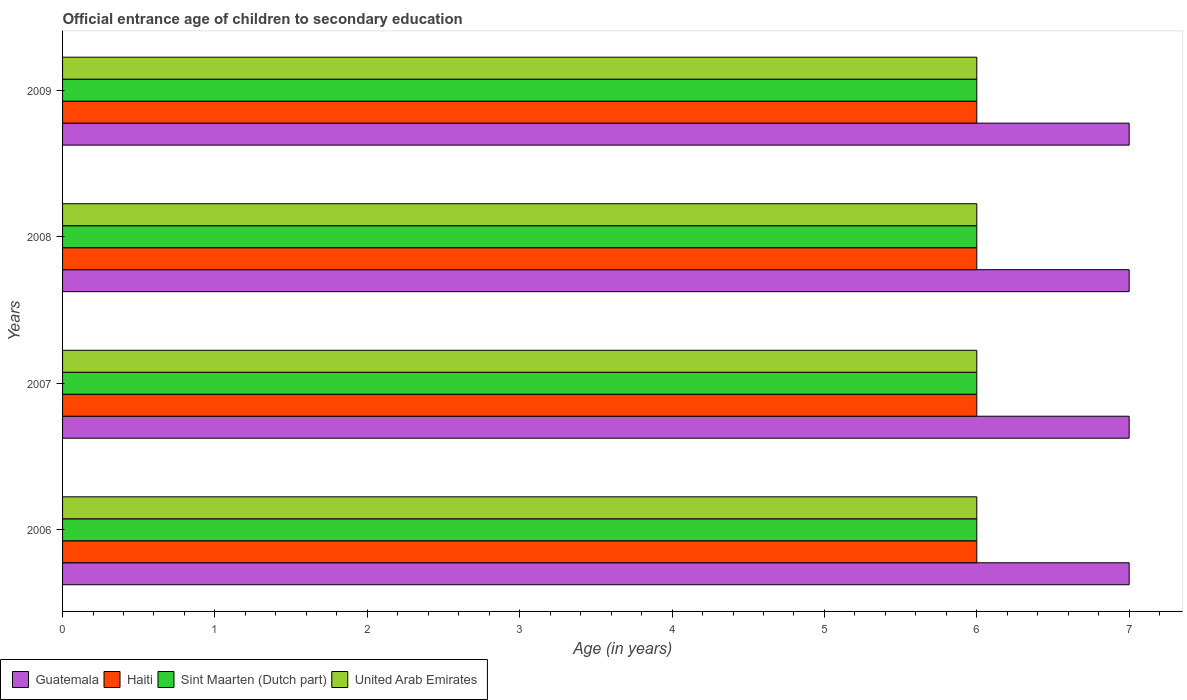How many different coloured bars are there?
Your answer should be compact. 4. How many groups of bars are there?
Give a very brief answer. 4. Are the number of bars per tick equal to the number of legend labels?
Your answer should be very brief. Yes. Are the number of bars on each tick of the Y-axis equal?
Your response must be concise. Yes. In how many cases, is the number of bars for a given year not equal to the number of legend labels?
Keep it short and to the point. 0. What is the secondary school starting age of children in Sint Maarten (Dutch part) in 2009?
Make the answer very short. 6. Across all years, what is the maximum secondary school starting age of children in Haiti?
Keep it short and to the point. 6. Across all years, what is the minimum secondary school starting age of children in Haiti?
Provide a succinct answer. 6. In which year was the secondary school starting age of children in United Arab Emirates maximum?
Offer a very short reply. 2006. What is the total secondary school starting age of children in Guatemala in the graph?
Your answer should be compact. 28. What is the difference between the secondary school starting age of children in Guatemala in 2009 and the secondary school starting age of children in Haiti in 2007?
Keep it short and to the point. 1. In the year 2007, what is the difference between the secondary school starting age of children in Guatemala and secondary school starting age of children in United Arab Emirates?
Provide a succinct answer. 1. Is the secondary school starting age of children in United Arab Emirates in 2008 less than that in 2009?
Your answer should be very brief. No. Is the difference between the secondary school starting age of children in Guatemala in 2008 and 2009 greater than the difference between the secondary school starting age of children in United Arab Emirates in 2008 and 2009?
Provide a succinct answer. No. Is the sum of the secondary school starting age of children in Sint Maarten (Dutch part) in 2006 and 2009 greater than the maximum secondary school starting age of children in United Arab Emirates across all years?
Provide a short and direct response. Yes. Is it the case that in every year, the sum of the secondary school starting age of children in United Arab Emirates and secondary school starting age of children in Haiti is greater than the sum of secondary school starting age of children in Sint Maarten (Dutch part) and secondary school starting age of children in Guatemala?
Offer a very short reply. No. What does the 1st bar from the top in 2007 represents?
Make the answer very short. United Arab Emirates. What does the 2nd bar from the bottom in 2008 represents?
Your answer should be very brief. Haiti. How many years are there in the graph?
Give a very brief answer. 4. How are the legend labels stacked?
Your answer should be very brief. Horizontal. What is the title of the graph?
Keep it short and to the point. Official entrance age of children to secondary education. Does "Liechtenstein" appear as one of the legend labels in the graph?
Make the answer very short. No. What is the label or title of the X-axis?
Offer a very short reply. Age (in years). What is the Age (in years) in Guatemala in 2006?
Keep it short and to the point. 7. What is the Age (in years) of Sint Maarten (Dutch part) in 2006?
Provide a short and direct response. 6. What is the Age (in years) of Guatemala in 2007?
Keep it short and to the point. 7. What is the Age (in years) of United Arab Emirates in 2007?
Provide a short and direct response. 6. What is the Age (in years) of Haiti in 2008?
Offer a very short reply. 6. What is the Age (in years) in Sint Maarten (Dutch part) in 2008?
Your answer should be compact. 6. What is the Age (in years) in Haiti in 2009?
Provide a short and direct response. 6. Across all years, what is the maximum Age (in years) in Guatemala?
Give a very brief answer. 7. Across all years, what is the maximum Age (in years) in Sint Maarten (Dutch part)?
Your answer should be very brief. 6. Across all years, what is the minimum Age (in years) in Haiti?
Give a very brief answer. 6. What is the total Age (in years) in Guatemala in the graph?
Provide a succinct answer. 28. What is the difference between the Age (in years) of Haiti in 2006 and that in 2007?
Make the answer very short. 0. What is the difference between the Age (in years) of United Arab Emirates in 2006 and that in 2007?
Your answer should be very brief. 0. What is the difference between the Age (in years) of Haiti in 2006 and that in 2008?
Offer a very short reply. 0. What is the difference between the Age (in years) in Sint Maarten (Dutch part) in 2006 and that in 2008?
Offer a terse response. 0. What is the difference between the Age (in years) in Haiti in 2006 and that in 2009?
Keep it short and to the point. 0. What is the difference between the Age (in years) in Sint Maarten (Dutch part) in 2006 and that in 2009?
Your response must be concise. 0. What is the difference between the Age (in years) in Guatemala in 2007 and that in 2008?
Give a very brief answer. 0. What is the difference between the Age (in years) of Sint Maarten (Dutch part) in 2007 and that in 2008?
Ensure brevity in your answer.  0. What is the difference between the Age (in years) of United Arab Emirates in 2007 and that in 2008?
Your answer should be very brief. 0. What is the difference between the Age (in years) in Guatemala in 2007 and that in 2009?
Your answer should be compact. 0. What is the difference between the Age (in years) of Haiti in 2007 and that in 2009?
Your response must be concise. 0. What is the difference between the Age (in years) in Sint Maarten (Dutch part) in 2007 and that in 2009?
Make the answer very short. 0. What is the difference between the Age (in years) of Guatemala in 2008 and that in 2009?
Offer a terse response. 0. What is the difference between the Age (in years) of Sint Maarten (Dutch part) in 2008 and that in 2009?
Give a very brief answer. 0. What is the difference between the Age (in years) in Guatemala in 2006 and the Age (in years) in Sint Maarten (Dutch part) in 2007?
Keep it short and to the point. 1. What is the difference between the Age (in years) in Haiti in 2006 and the Age (in years) in Sint Maarten (Dutch part) in 2007?
Ensure brevity in your answer.  0. What is the difference between the Age (in years) of Haiti in 2006 and the Age (in years) of United Arab Emirates in 2007?
Offer a very short reply. 0. What is the difference between the Age (in years) of Guatemala in 2006 and the Age (in years) of Haiti in 2008?
Make the answer very short. 1. What is the difference between the Age (in years) in Guatemala in 2006 and the Age (in years) in United Arab Emirates in 2008?
Your answer should be very brief. 1. What is the difference between the Age (in years) of Sint Maarten (Dutch part) in 2006 and the Age (in years) of United Arab Emirates in 2008?
Make the answer very short. 0. What is the difference between the Age (in years) of Guatemala in 2006 and the Age (in years) of Haiti in 2009?
Make the answer very short. 1. What is the difference between the Age (in years) of Guatemala in 2006 and the Age (in years) of Sint Maarten (Dutch part) in 2009?
Offer a very short reply. 1. What is the difference between the Age (in years) in Guatemala in 2006 and the Age (in years) in United Arab Emirates in 2009?
Provide a succinct answer. 1. What is the difference between the Age (in years) of Haiti in 2006 and the Age (in years) of Sint Maarten (Dutch part) in 2009?
Provide a succinct answer. 0. What is the difference between the Age (in years) in Haiti in 2006 and the Age (in years) in United Arab Emirates in 2009?
Your answer should be compact. 0. What is the difference between the Age (in years) of Sint Maarten (Dutch part) in 2006 and the Age (in years) of United Arab Emirates in 2009?
Give a very brief answer. 0. What is the difference between the Age (in years) in Guatemala in 2007 and the Age (in years) in Haiti in 2008?
Make the answer very short. 1. What is the difference between the Age (in years) of Guatemala in 2007 and the Age (in years) of United Arab Emirates in 2008?
Provide a short and direct response. 1. What is the difference between the Age (in years) in Guatemala in 2007 and the Age (in years) in Haiti in 2009?
Ensure brevity in your answer.  1. What is the difference between the Age (in years) of Guatemala in 2007 and the Age (in years) of United Arab Emirates in 2009?
Offer a terse response. 1. What is the difference between the Age (in years) of Sint Maarten (Dutch part) in 2007 and the Age (in years) of United Arab Emirates in 2009?
Your answer should be very brief. 0. What is the difference between the Age (in years) of Guatemala in 2008 and the Age (in years) of Haiti in 2009?
Make the answer very short. 1. What is the difference between the Age (in years) of Guatemala in 2008 and the Age (in years) of Sint Maarten (Dutch part) in 2009?
Your answer should be very brief. 1. What is the difference between the Age (in years) of Haiti in 2008 and the Age (in years) of Sint Maarten (Dutch part) in 2009?
Give a very brief answer. 0. What is the difference between the Age (in years) of Sint Maarten (Dutch part) in 2008 and the Age (in years) of United Arab Emirates in 2009?
Give a very brief answer. 0. What is the average Age (in years) in Sint Maarten (Dutch part) per year?
Offer a terse response. 6. What is the average Age (in years) of United Arab Emirates per year?
Provide a succinct answer. 6. In the year 2006, what is the difference between the Age (in years) of Guatemala and Age (in years) of Haiti?
Your response must be concise. 1. In the year 2006, what is the difference between the Age (in years) in Guatemala and Age (in years) in United Arab Emirates?
Offer a terse response. 1. In the year 2006, what is the difference between the Age (in years) of Haiti and Age (in years) of Sint Maarten (Dutch part)?
Your answer should be compact. 0. In the year 2006, what is the difference between the Age (in years) of Haiti and Age (in years) of United Arab Emirates?
Give a very brief answer. 0. In the year 2007, what is the difference between the Age (in years) in Guatemala and Age (in years) in Sint Maarten (Dutch part)?
Give a very brief answer. 1. In the year 2007, what is the difference between the Age (in years) in Haiti and Age (in years) in Sint Maarten (Dutch part)?
Offer a very short reply. 0. In the year 2007, what is the difference between the Age (in years) in Sint Maarten (Dutch part) and Age (in years) in United Arab Emirates?
Offer a very short reply. 0. In the year 2008, what is the difference between the Age (in years) of Haiti and Age (in years) of United Arab Emirates?
Provide a short and direct response. 0. In the year 2009, what is the difference between the Age (in years) of Guatemala and Age (in years) of Haiti?
Make the answer very short. 1. What is the ratio of the Age (in years) in Guatemala in 2006 to that in 2007?
Your response must be concise. 1. What is the ratio of the Age (in years) of Haiti in 2006 to that in 2007?
Your response must be concise. 1. What is the ratio of the Age (in years) of Sint Maarten (Dutch part) in 2006 to that in 2007?
Your answer should be compact. 1. What is the ratio of the Age (in years) of Haiti in 2006 to that in 2009?
Offer a very short reply. 1. What is the ratio of the Age (in years) of Sint Maarten (Dutch part) in 2006 to that in 2009?
Provide a short and direct response. 1. What is the ratio of the Age (in years) in Guatemala in 2007 to that in 2008?
Your response must be concise. 1. What is the ratio of the Age (in years) in Haiti in 2007 to that in 2008?
Offer a terse response. 1. What is the ratio of the Age (in years) in Guatemala in 2007 to that in 2009?
Your answer should be compact. 1. What is the ratio of the Age (in years) of Haiti in 2007 to that in 2009?
Offer a very short reply. 1. What is the ratio of the Age (in years) of United Arab Emirates in 2007 to that in 2009?
Your response must be concise. 1. What is the ratio of the Age (in years) of Guatemala in 2008 to that in 2009?
Provide a short and direct response. 1. What is the ratio of the Age (in years) in Haiti in 2008 to that in 2009?
Ensure brevity in your answer.  1. What is the ratio of the Age (in years) in Sint Maarten (Dutch part) in 2008 to that in 2009?
Offer a terse response. 1. What is the ratio of the Age (in years) in United Arab Emirates in 2008 to that in 2009?
Your answer should be very brief. 1. What is the difference between the highest and the second highest Age (in years) in Guatemala?
Make the answer very short. 0. What is the difference between the highest and the second highest Age (in years) of Sint Maarten (Dutch part)?
Your answer should be very brief. 0. What is the difference between the highest and the second highest Age (in years) of United Arab Emirates?
Your answer should be very brief. 0. What is the difference between the highest and the lowest Age (in years) of Haiti?
Offer a terse response. 0. What is the difference between the highest and the lowest Age (in years) of Sint Maarten (Dutch part)?
Your response must be concise. 0. 